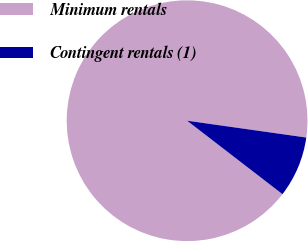<chart> <loc_0><loc_0><loc_500><loc_500><pie_chart><fcel>Minimum rentals<fcel>Contingent rentals (1)<nl><fcel>91.79%<fcel>8.21%<nl></chart> 